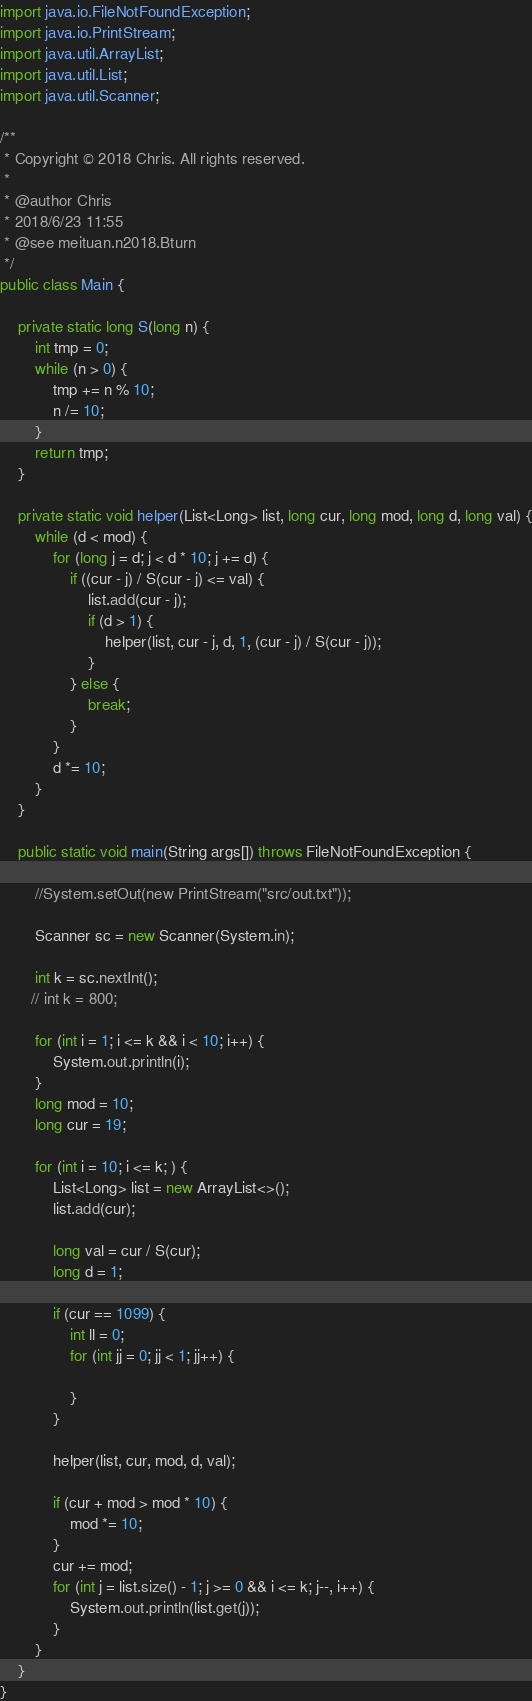Convert code to text. <code><loc_0><loc_0><loc_500><loc_500><_Java_>import java.io.FileNotFoundException;
import java.io.PrintStream;
import java.util.ArrayList;
import java.util.List;
import java.util.Scanner;

/**
 * Copyright © 2018 Chris. All rights reserved.
 *
 * @author Chris
 * 2018/6/23 11:55
 * @see meituan.n2018.Bturn
 */
public class Main {

    private static long S(long n) {
        int tmp = 0;
        while (n > 0) {
            tmp += n % 10;
            n /= 10;
        }
        return tmp;
    }

    private static void helper(List<Long> list, long cur, long mod, long d, long val) {
        while (d < mod) {
            for (long j = d; j < d * 10; j += d) {
                if ((cur - j) / S(cur - j) <= val) {
                    list.add(cur - j);
                    if (d > 1) {
                        helper(list, cur - j, d, 1, (cur - j) / S(cur - j));
                    }
                } else {
                    break;
                }
            }
            d *= 10;
        }
    }

    public static void main(String args[]) throws FileNotFoundException {

        //System.setOut(new PrintStream("src/out.txt"));

        Scanner sc = new Scanner(System.in);

        int k = sc.nextInt();
       // int k = 800;

        for (int i = 1; i <= k && i < 10; i++) {
            System.out.println(i);
        }
        long mod = 10;
        long cur = 19;

        for (int i = 10; i <= k; ) {
            List<Long> list = new ArrayList<>();
            list.add(cur);

            long val = cur / S(cur);
            long d = 1;

            if (cur == 1099) {
                int ll = 0;
                for (int jj = 0; jj < 1; jj++) {

                }
            }

            helper(list, cur, mod, d, val);

            if (cur + mod > mod * 10) {
                mod *= 10;
            }
            cur += mod;
            for (int j = list.size() - 1; j >= 0 && i <= k; j--, i++) {
                System.out.println(list.get(j));
            }
        }
    }
}
</code> 